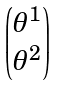Convert formula to latex. <formula><loc_0><loc_0><loc_500><loc_500>\begin{pmatrix} \theta ^ { 1 } \\ \theta ^ { 2 } \end{pmatrix}</formula> 